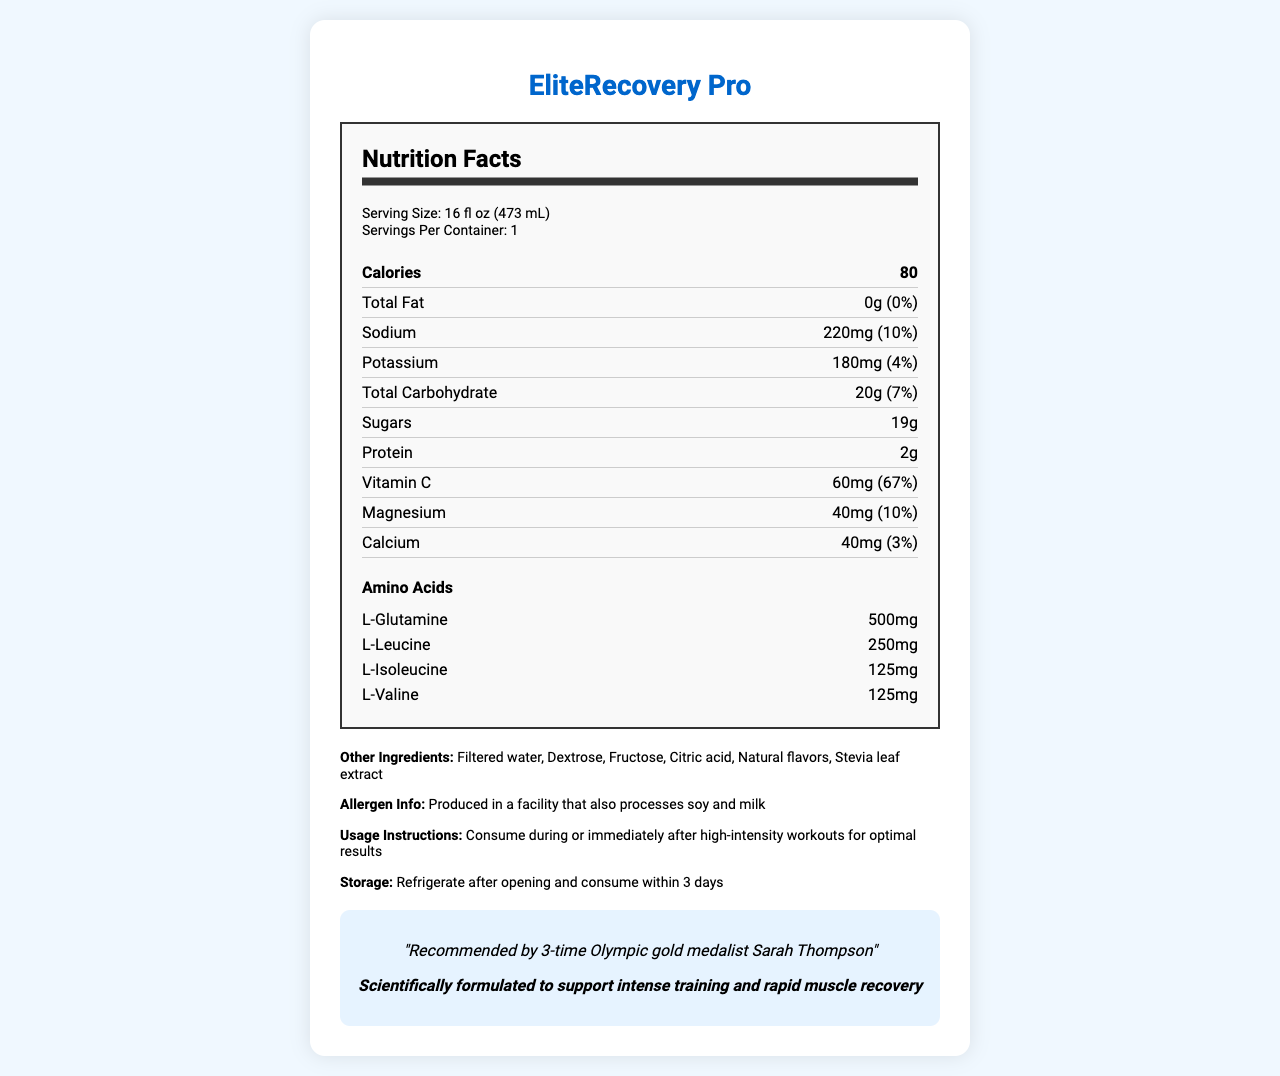what is the serving size? The serving size is explicitly stated in the document as 16 fl oz (473 mL).
Answer: 16 fl oz (473 mL) How many servings are there per container? The document indicates that there is 1 serving per container.
Answer: 1 What is the total carbohydrate content per serving? The document lists the total carbohydrate content per serving as 20g.
Answer: 20g What is the amount of sugars in the drink? The document states that the sugars amount to 19g.
Answer: 19g How much protein does the drink contain? The document specifies that the drink contains 2g of protein.
Answer: 2g What percentage of the Daily Value for sodium does the drink contain? The document specifies that the sodium content is 220mg, which is 10% of the Daily Value.
Answer: 10% Which amino acid has the highest amount in the drink? A. L-Glutamine B. L-Leucine C. L-Isoleucine D. L-Valine The document states that L-Glutamine has a content of 500mg, which is higher than the other listed amino acids.
Answer: A. L-Glutamine What is the daily value percentage of Vitamin C in the drink? According to the document, the drink contains 67% of the Daily Value for Vitamin C.
Answer: 67% Which mineral is present with an amount of 40mg in the drink? A. Sodium B. Potassium C. Magnesium D. Calcium The document lists calcium as 40mg, whereas other minerals have different values.
Answer: D. Calcium Is the drink produced in a facility that processes any allergens? The document mentions that the drink is produced in a facility that also processes soy and milk.
Answer: Yes Summarize the main idea of the document. The document outlines the nutritional profile and benefits of EliteRecovery Pro, its ingredients, allergen information, and endorsements, making it clear that the drink is designed for athletes aiming for recovery and performance enhancement.
Answer: The document provides detailed nutritional information about the "EliteRecovery Pro" sports drink, including serving size, macro and micronutrient content, amino acids, and other ingredients. It highlights the drink's benefits for muscle recovery, endorses its usage by an Olympic athlete, and includes usage and storage instructions. What is the exact amount of magnesium in percentage of Daily Value? The document states that the magnesium content is 40mg, which corresponds to 10% of the Daily Value.
Answer: 10% Who endorses this sports drink? The document explicitly mentions that the drink is recommended by 3-time Olympic gold medalist Sarah Thompson.
Answer: 3-time Olympic gold medalist Sarah Thompson What are the primary sources of sweetness in this drink? The primary sources of sweetness in the drink, as mentioned in the document, are dextrose, fructose, and stevia leaf extract.
Answer: Dextrose, Fructose, Stevia leaf extract What claim does the document make about the effect of the drink? A. It improves mental focus B. It supports intense training and rapid muscle recovery C. It helps in weight loss D. It enhances sleep quality The document claims that the drink is scientifically formulated to support intense training and rapid muscle recovery.
Answer: B. It supports intense training and rapid muscle recovery Does the document provide information about the best time to consume the drink? The document advises consuming the drink during or immediately after high-intensity workouts for optimal results.
Answer: Yes What is the storage recommendation after opening the drink? The document specifies that the drink should be refrigerated after opening and consumed within 3 days.
Answer: Refrigerate after opening and consume within 3 days What is the concentration of L-Leucine in the drink? The document lists the concentration of L-Leucine as 250mg.
Answer: 250mg How much calcium in percentage does it provide? The document indicates that the calcium content corresponds to 3% of the Daily Value.
Answer: 3% What is the main athletic benefit of this drink? The document highlights that the drink is formulated to support rapid muscle recovery.
Answer: Rapid muscle recovery What specific flavor is the drink? The document does not provide specific details about the flavor of the drink.
Answer: Not enough information 